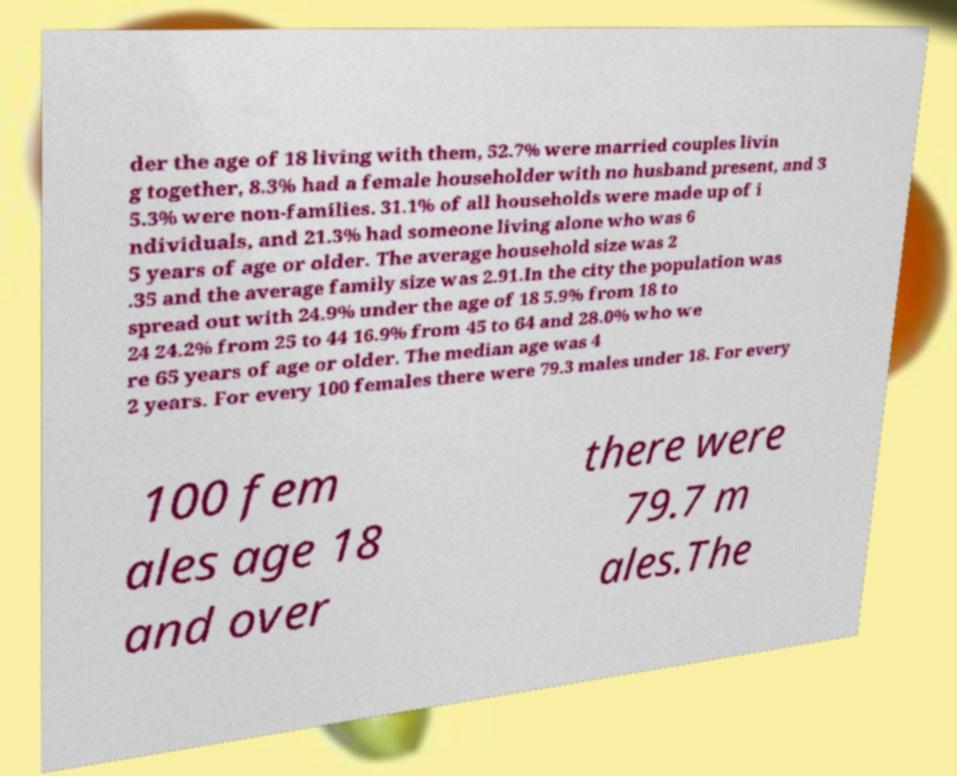Please identify and transcribe the text found in this image. der the age of 18 living with them, 52.7% were married couples livin g together, 8.3% had a female householder with no husband present, and 3 5.3% were non-families. 31.1% of all households were made up of i ndividuals, and 21.3% had someone living alone who was 6 5 years of age or older. The average household size was 2 .35 and the average family size was 2.91.In the city the population was spread out with 24.9% under the age of 18 5.9% from 18 to 24 24.2% from 25 to 44 16.9% from 45 to 64 and 28.0% who we re 65 years of age or older. The median age was 4 2 years. For every 100 females there were 79.3 males under 18. For every 100 fem ales age 18 and over there were 79.7 m ales.The 